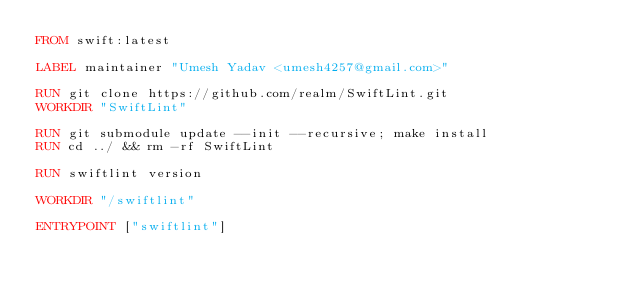<code> <loc_0><loc_0><loc_500><loc_500><_Dockerfile_>FROM swift:latest

LABEL maintainer "Umesh Yadav <umesh4257@gmail.com>"

RUN git clone https://github.com/realm/SwiftLint.git
WORKDIR "SwiftLint"

RUN git submodule update --init --recursive; make install
RUN cd ../ && rm -rf SwiftLint

RUN swiftlint version

WORKDIR "/swiftlint"

ENTRYPOINT ["swiftlint"]
</code> 